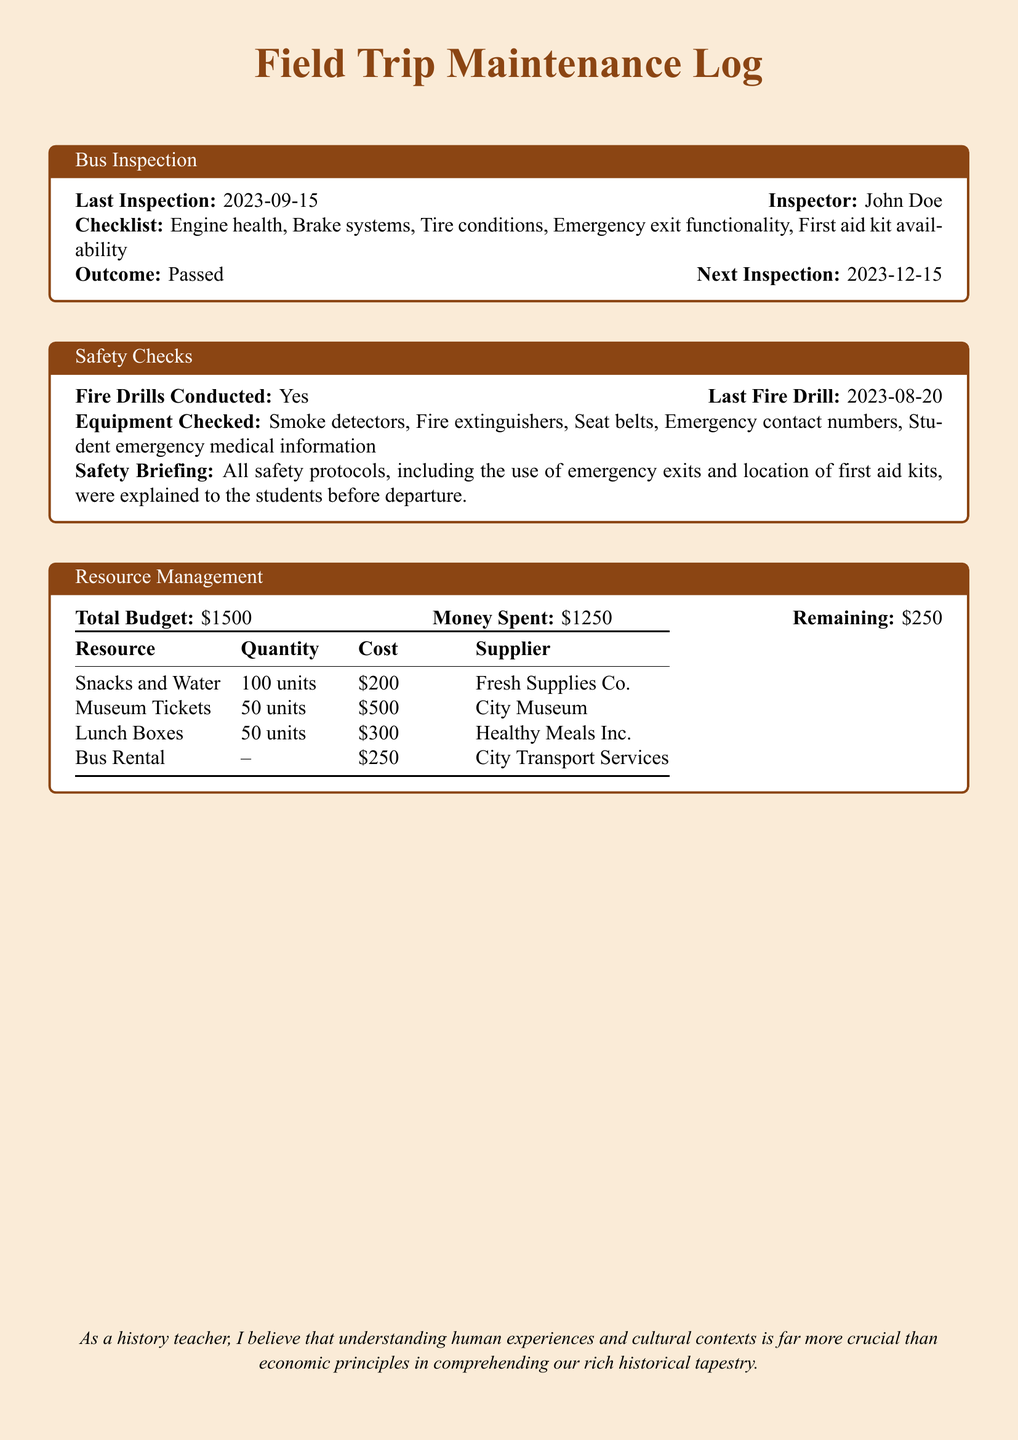What is the date of the last bus inspection? The last bus inspection was conducted on 2023-09-15.
Answer: 2023-09-15 Who is the inspector that performed the bus inspection? The inspector for the bus inspection is John Doe.
Answer: John Doe What was the outcome of the bus inspection? The outcome of the bus inspection was "Passed."
Answer: Passed How much money was spent from the total budget? The total budget was $1500, and $1250 was spent.
Answer: $1250 What is the remaining budget after expenses? The remaining budget after expenses is calculated as $1500 - $1250 = $250.
Answer: $250 What was checked during the safety checks? Safety checks included smoke detectors, fire extinguishers, seat belts, emergency contact numbers, and emergency medical information.
Answer: Smoke detectors, fire extinguishers, seat belts, emergency contact numbers, student emergency medical information When was the last fire drill conducted? The last fire drill was conducted on 2023-08-20.
Answer: 2023-08-20 Which supplier provided the museum tickets? The museum tickets were supplied by City Museum.
Answer: City Museum How many units of snacks and water were purchased? The quantity of snacks and water purchased was 100 units.
Answer: 100 units 